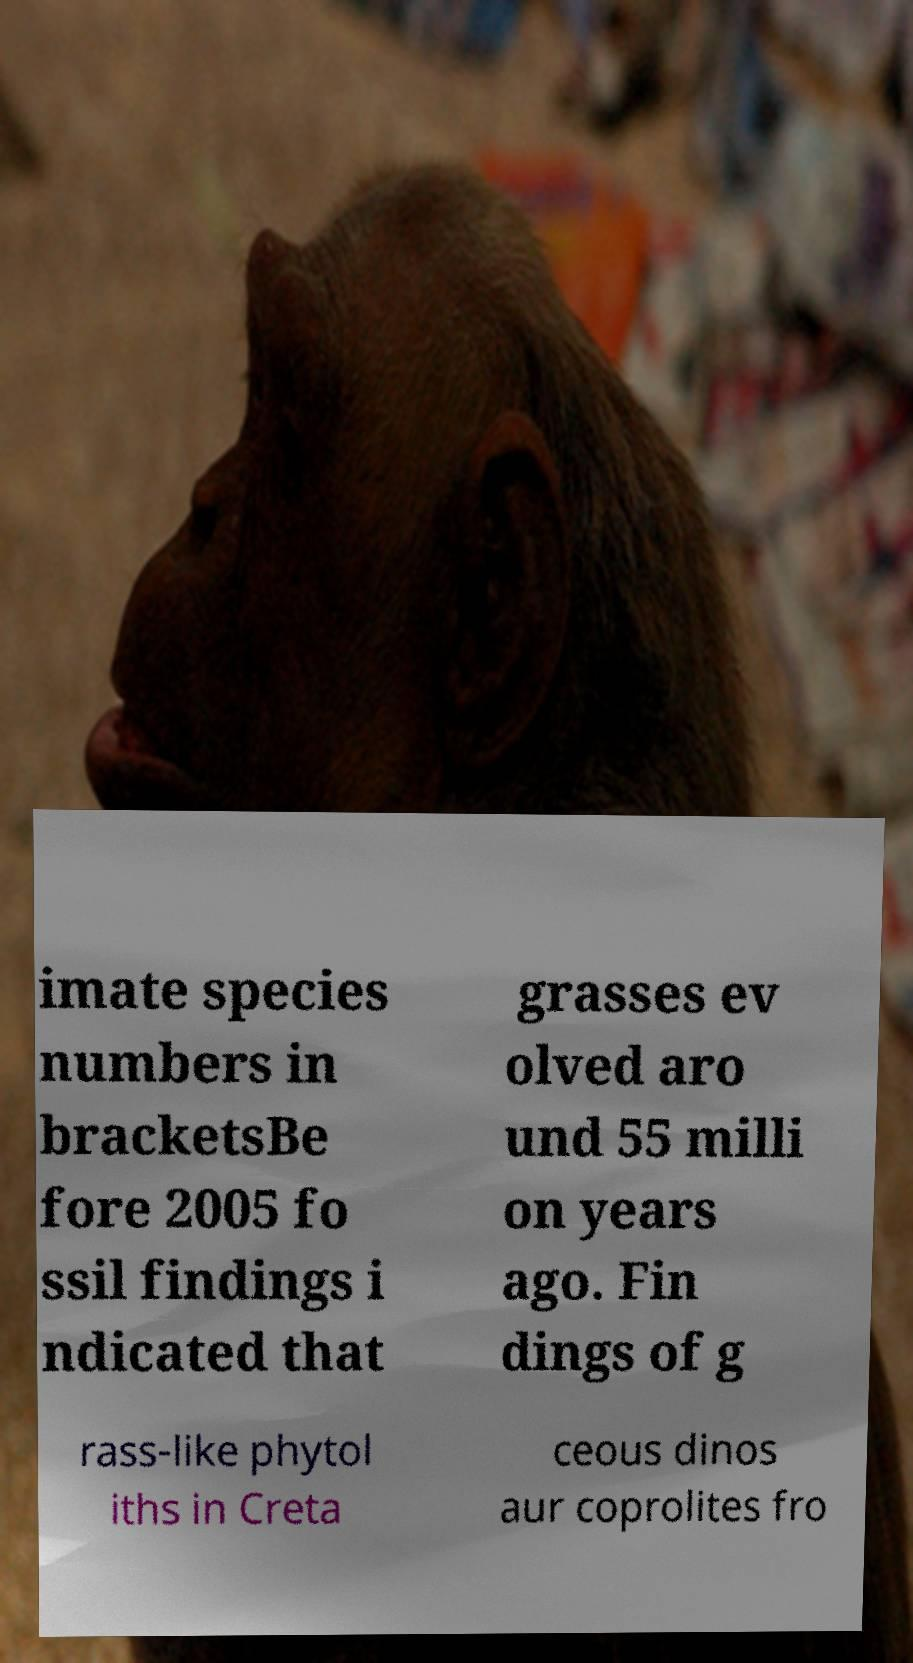Could you extract and type out the text from this image? imate species numbers in bracketsBe fore 2005 fo ssil findings i ndicated that grasses ev olved aro und 55 milli on years ago. Fin dings of g rass-like phytol iths in Creta ceous dinos aur coprolites fro 